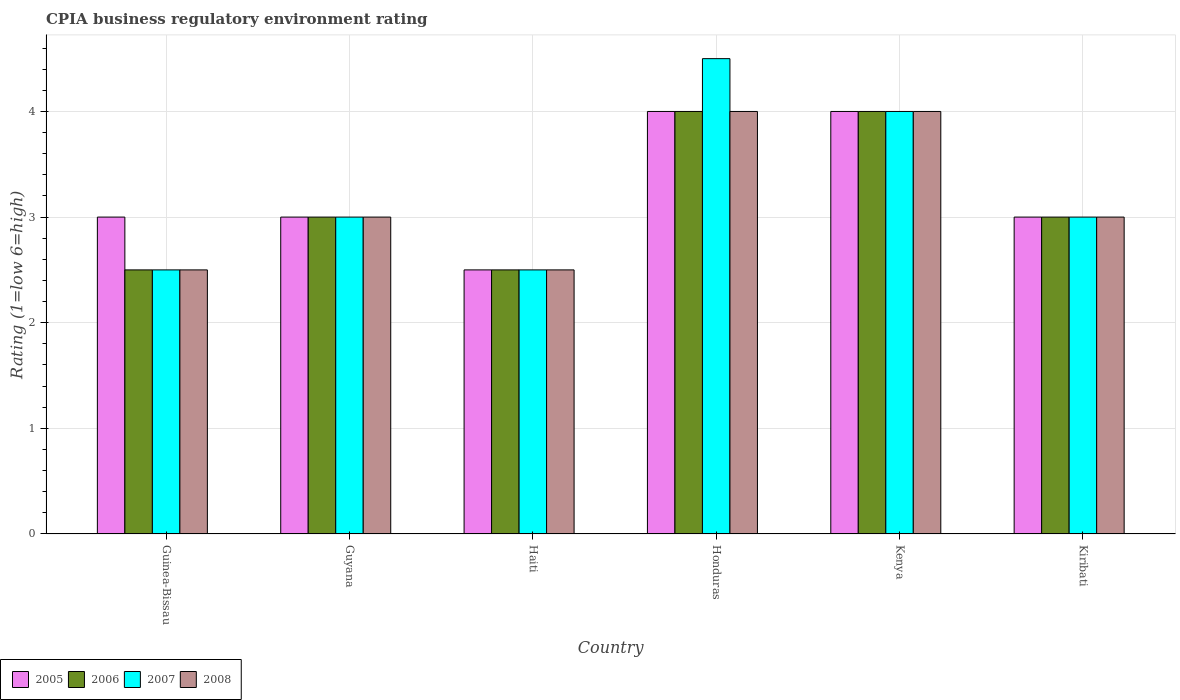How many different coloured bars are there?
Ensure brevity in your answer.  4. How many groups of bars are there?
Make the answer very short. 6. Are the number of bars on each tick of the X-axis equal?
Ensure brevity in your answer.  Yes. What is the label of the 1st group of bars from the left?
Provide a short and direct response. Guinea-Bissau. In how many cases, is the number of bars for a given country not equal to the number of legend labels?
Ensure brevity in your answer.  0. Across all countries, what is the maximum CPIA rating in 2006?
Your response must be concise. 4. Across all countries, what is the minimum CPIA rating in 2006?
Your response must be concise. 2.5. In which country was the CPIA rating in 2008 maximum?
Offer a terse response. Honduras. In which country was the CPIA rating in 2007 minimum?
Ensure brevity in your answer.  Guinea-Bissau. What is the total CPIA rating in 2007 in the graph?
Offer a terse response. 19.5. Is the CPIA rating in 2005 in Kenya less than that in Kiribati?
Provide a short and direct response. No. What is the difference between the highest and the lowest CPIA rating in 2008?
Your response must be concise. 1.5. Is it the case that in every country, the sum of the CPIA rating in 2008 and CPIA rating in 2007 is greater than the CPIA rating in 2005?
Give a very brief answer. Yes. How many bars are there?
Keep it short and to the point. 24. Are all the bars in the graph horizontal?
Your answer should be compact. No. Does the graph contain grids?
Keep it short and to the point. Yes. Where does the legend appear in the graph?
Your answer should be very brief. Bottom left. How many legend labels are there?
Your answer should be very brief. 4. How are the legend labels stacked?
Provide a succinct answer. Horizontal. What is the title of the graph?
Provide a succinct answer. CPIA business regulatory environment rating. Does "1993" appear as one of the legend labels in the graph?
Provide a short and direct response. No. What is the label or title of the X-axis?
Your response must be concise. Country. What is the Rating (1=low 6=high) in 2007 in Guinea-Bissau?
Your answer should be very brief. 2.5. What is the Rating (1=low 6=high) in 2008 in Guinea-Bissau?
Offer a terse response. 2.5. What is the Rating (1=low 6=high) in 2006 in Haiti?
Offer a very short reply. 2.5. What is the Rating (1=low 6=high) of 2007 in Haiti?
Keep it short and to the point. 2.5. What is the Rating (1=low 6=high) of 2008 in Haiti?
Keep it short and to the point. 2.5. What is the Rating (1=low 6=high) of 2005 in Honduras?
Offer a very short reply. 4. What is the Rating (1=low 6=high) in 2006 in Honduras?
Provide a short and direct response. 4. What is the Rating (1=low 6=high) of 2007 in Honduras?
Your answer should be compact. 4.5. What is the Rating (1=low 6=high) of 2005 in Kenya?
Your response must be concise. 4. What is the Rating (1=low 6=high) in 2007 in Kenya?
Provide a short and direct response. 4. What is the Rating (1=low 6=high) in 2006 in Kiribati?
Make the answer very short. 3. What is the Rating (1=low 6=high) in 2007 in Kiribati?
Your answer should be very brief. 3. Across all countries, what is the maximum Rating (1=low 6=high) in 2005?
Provide a short and direct response. 4. Across all countries, what is the maximum Rating (1=low 6=high) of 2006?
Your answer should be very brief. 4. Across all countries, what is the minimum Rating (1=low 6=high) of 2006?
Your answer should be compact. 2.5. Across all countries, what is the minimum Rating (1=low 6=high) in 2008?
Your answer should be very brief. 2.5. What is the total Rating (1=low 6=high) in 2005 in the graph?
Provide a succinct answer. 19.5. What is the total Rating (1=low 6=high) in 2006 in the graph?
Provide a short and direct response. 19. What is the total Rating (1=low 6=high) in 2007 in the graph?
Keep it short and to the point. 19.5. What is the total Rating (1=low 6=high) of 2008 in the graph?
Your answer should be very brief. 19. What is the difference between the Rating (1=low 6=high) in 2008 in Guinea-Bissau and that in Guyana?
Offer a very short reply. -0.5. What is the difference between the Rating (1=low 6=high) in 2006 in Guinea-Bissau and that in Haiti?
Your answer should be very brief. 0. What is the difference between the Rating (1=low 6=high) in 2007 in Guinea-Bissau and that in Haiti?
Provide a succinct answer. 0. What is the difference between the Rating (1=low 6=high) in 2008 in Guinea-Bissau and that in Haiti?
Your response must be concise. 0. What is the difference between the Rating (1=low 6=high) in 2006 in Guinea-Bissau and that in Honduras?
Your answer should be very brief. -1.5. What is the difference between the Rating (1=low 6=high) of 2005 in Guinea-Bissau and that in Kenya?
Your answer should be very brief. -1. What is the difference between the Rating (1=low 6=high) in 2007 in Guinea-Bissau and that in Kenya?
Your response must be concise. -1.5. What is the difference between the Rating (1=low 6=high) of 2006 in Guyana and that in Haiti?
Keep it short and to the point. 0.5. What is the difference between the Rating (1=low 6=high) in 2008 in Guyana and that in Honduras?
Offer a very short reply. -1. What is the difference between the Rating (1=low 6=high) of 2005 in Guyana and that in Kenya?
Keep it short and to the point. -1. What is the difference between the Rating (1=low 6=high) of 2007 in Guyana and that in Kenya?
Offer a terse response. -1. What is the difference between the Rating (1=low 6=high) in 2005 in Guyana and that in Kiribati?
Offer a very short reply. 0. What is the difference between the Rating (1=low 6=high) in 2007 in Guyana and that in Kiribati?
Offer a very short reply. 0. What is the difference between the Rating (1=low 6=high) of 2006 in Haiti and that in Honduras?
Provide a short and direct response. -1.5. What is the difference between the Rating (1=low 6=high) in 2008 in Haiti and that in Honduras?
Keep it short and to the point. -1.5. What is the difference between the Rating (1=low 6=high) of 2006 in Haiti and that in Kenya?
Provide a short and direct response. -1.5. What is the difference between the Rating (1=low 6=high) of 2007 in Haiti and that in Kenya?
Give a very brief answer. -1.5. What is the difference between the Rating (1=low 6=high) of 2008 in Haiti and that in Kenya?
Make the answer very short. -1.5. What is the difference between the Rating (1=low 6=high) of 2006 in Haiti and that in Kiribati?
Your response must be concise. -0.5. What is the difference between the Rating (1=low 6=high) of 2007 in Haiti and that in Kiribati?
Offer a very short reply. -0.5. What is the difference between the Rating (1=low 6=high) of 2008 in Haiti and that in Kiribati?
Offer a terse response. -0.5. What is the difference between the Rating (1=low 6=high) in 2005 in Honduras and that in Kenya?
Give a very brief answer. 0. What is the difference between the Rating (1=low 6=high) of 2006 in Honduras and that in Kenya?
Provide a short and direct response. 0. What is the difference between the Rating (1=low 6=high) in 2007 in Honduras and that in Kenya?
Provide a short and direct response. 0.5. What is the difference between the Rating (1=low 6=high) of 2005 in Honduras and that in Kiribati?
Your answer should be very brief. 1. What is the difference between the Rating (1=low 6=high) of 2006 in Honduras and that in Kiribati?
Make the answer very short. 1. What is the difference between the Rating (1=low 6=high) in 2007 in Honduras and that in Kiribati?
Make the answer very short. 1.5. What is the difference between the Rating (1=low 6=high) in 2008 in Honduras and that in Kiribati?
Offer a very short reply. 1. What is the difference between the Rating (1=low 6=high) in 2005 in Kenya and that in Kiribati?
Your answer should be compact. 1. What is the difference between the Rating (1=low 6=high) of 2008 in Kenya and that in Kiribati?
Provide a succinct answer. 1. What is the difference between the Rating (1=low 6=high) in 2005 in Guinea-Bissau and the Rating (1=low 6=high) in 2006 in Guyana?
Give a very brief answer. 0. What is the difference between the Rating (1=low 6=high) of 2005 in Guinea-Bissau and the Rating (1=low 6=high) of 2007 in Guyana?
Ensure brevity in your answer.  0. What is the difference between the Rating (1=low 6=high) of 2006 in Guinea-Bissau and the Rating (1=low 6=high) of 2008 in Guyana?
Provide a short and direct response. -0.5. What is the difference between the Rating (1=low 6=high) of 2007 in Guinea-Bissau and the Rating (1=low 6=high) of 2008 in Guyana?
Give a very brief answer. -0.5. What is the difference between the Rating (1=low 6=high) in 2005 in Guinea-Bissau and the Rating (1=low 6=high) in 2007 in Haiti?
Offer a terse response. 0.5. What is the difference between the Rating (1=low 6=high) of 2005 in Guinea-Bissau and the Rating (1=low 6=high) of 2008 in Honduras?
Make the answer very short. -1. What is the difference between the Rating (1=low 6=high) in 2006 in Guinea-Bissau and the Rating (1=low 6=high) in 2007 in Honduras?
Your response must be concise. -2. What is the difference between the Rating (1=low 6=high) of 2006 in Guinea-Bissau and the Rating (1=low 6=high) of 2008 in Honduras?
Your answer should be very brief. -1.5. What is the difference between the Rating (1=low 6=high) of 2005 in Guinea-Bissau and the Rating (1=low 6=high) of 2006 in Kenya?
Give a very brief answer. -1. What is the difference between the Rating (1=low 6=high) in 2005 in Guinea-Bissau and the Rating (1=low 6=high) in 2008 in Kenya?
Give a very brief answer. -1. What is the difference between the Rating (1=low 6=high) in 2006 in Guinea-Bissau and the Rating (1=low 6=high) in 2007 in Kenya?
Offer a terse response. -1.5. What is the difference between the Rating (1=low 6=high) in 2005 in Guinea-Bissau and the Rating (1=low 6=high) in 2006 in Kiribati?
Your response must be concise. 0. What is the difference between the Rating (1=low 6=high) of 2007 in Guinea-Bissau and the Rating (1=low 6=high) of 2008 in Kiribati?
Keep it short and to the point. -0.5. What is the difference between the Rating (1=low 6=high) in 2005 in Guyana and the Rating (1=low 6=high) in 2008 in Haiti?
Your answer should be very brief. 0.5. What is the difference between the Rating (1=low 6=high) in 2006 in Guyana and the Rating (1=low 6=high) in 2007 in Haiti?
Ensure brevity in your answer.  0.5. What is the difference between the Rating (1=low 6=high) in 2005 in Guyana and the Rating (1=low 6=high) in 2006 in Honduras?
Your answer should be compact. -1. What is the difference between the Rating (1=low 6=high) of 2005 in Guyana and the Rating (1=low 6=high) of 2007 in Honduras?
Provide a succinct answer. -1.5. What is the difference between the Rating (1=low 6=high) of 2006 in Guyana and the Rating (1=low 6=high) of 2007 in Honduras?
Make the answer very short. -1.5. What is the difference between the Rating (1=low 6=high) of 2007 in Guyana and the Rating (1=low 6=high) of 2008 in Honduras?
Keep it short and to the point. -1. What is the difference between the Rating (1=low 6=high) in 2005 in Guyana and the Rating (1=low 6=high) in 2007 in Kenya?
Ensure brevity in your answer.  -1. What is the difference between the Rating (1=low 6=high) in 2005 in Guyana and the Rating (1=low 6=high) in 2008 in Kenya?
Make the answer very short. -1. What is the difference between the Rating (1=low 6=high) of 2007 in Guyana and the Rating (1=low 6=high) of 2008 in Kenya?
Give a very brief answer. -1. What is the difference between the Rating (1=low 6=high) of 2005 in Guyana and the Rating (1=low 6=high) of 2008 in Kiribati?
Provide a succinct answer. 0. What is the difference between the Rating (1=low 6=high) of 2007 in Guyana and the Rating (1=low 6=high) of 2008 in Kiribati?
Offer a very short reply. 0. What is the difference between the Rating (1=low 6=high) in 2005 in Haiti and the Rating (1=low 6=high) in 2008 in Honduras?
Provide a succinct answer. -1.5. What is the difference between the Rating (1=low 6=high) of 2005 in Haiti and the Rating (1=low 6=high) of 2008 in Kenya?
Provide a short and direct response. -1.5. What is the difference between the Rating (1=low 6=high) of 2006 in Haiti and the Rating (1=low 6=high) of 2007 in Kenya?
Your answer should be compact. -1.5. What is the difference between the Rating (1=low 6=high) of 2007 in Haiti and the Rating (1=low 6=high) of 2008 in Kenya?
Keep it short and to the point. -1.5. What is the difference between the Rating (1=low 6=high) in 2005 in Haiti and the Rating (1=low 6=high) in 2007 in Kiribati?
Offer a very short reply. -0.5. What is the difference between the Rating (1=low 6=high) of 2006 in Haiti and the Rating (1=low 6=high) of 2008 in Kiribati?
Give a very brief answer. -0.5. What is the difference between the Rating (1=low 6=high) in 2005 in Honduras and the Rating (1=low 6=high) in 2008 in Kenya?
Provide a short and direct response. 0. What is the difference between the Rating (1=low 6=high) of 2006 in Honduras and the Rating (1=low 6=high) of 2007 in Kenya?
Your answer should be very brief. 0. What is the difference between the Rating (1=low 6=high) in 2006 in Honduras and the Rating (1=low 6=high) in 2008 in Kenya?
Your response must be concise. 0. What is the difference between the Rating (1=low 6=high) of 2005 in Honduras and the Rating (1=low 6=high) of 2006 in Kiribati?
Offer a terse response. 1. What is the difference between the Rating (1=low 6=high) in 2005 in Honduras and the Rating (1=low 6=high) in 2007 in Kiribati?
Your answer should be compact. 1. What is the difference between the Rating (1=low 6=high) of 2005 in Honduras and the Rating (1=low 6=high) of 2008 in Kiribati?
Make the answer very short. 1. What is the difference between the Rating (1=low 6=high) in 2007 in Honduras and the Rating (1=low 6=high) in 2008 in Kiribati?
Provide a succinct answer. 1.5. What is the difference between the Rating (1=low 6=high) of 2005 in Kenya and the Rating (1=low 6=high) of 2006 in Kiribati?
Your answer should be very brief. 1. What is the difference between the Rating (1=low 6=high) of 2005 in Kenya and the Rating (1=low 6=high) of 2007 in Kiribati?
Your answer should be very brief. 1. What is the difference between the Rating (1=low 6=high) of 2005 in Kenya and the Rating (1=low 6=high) of 2008 in Kiribati?
Provide a short and direct response. 1. What is the difference between the Rating (1=low 6=high) in 2006 in Kenya and the Rating (1=low 6=high) in 2007 in Kiribati?
Offer a terse response. 1. What is the difference between the Rating (1=low 6=high) in 2007 in Kenya and the Rating (1=low 6=high) in 2008 in Kiribati?
Provide a short and direct response. 1. What is the average Rating (1=low 6=high) of 2005 per country?
Make the answer very short. 3.25. What is the average Rating (1=low 6=high) of 2006 per country?
Your response must be concise. 3.17. What is the average Rating (1=low 6=high) of 2007 per country?
Provide a succinct answer. 3.25. What is the average Rating (1=low 6=high) in 2008 per country?
Provide a succinct answer. 3.17. What is the difference between the Rating (1=low 6=high) in 2005 and Rating (1=low 6=high) in 2008 in Guinea-Bissau?
Make the answer very short. 0.5. What is the difference between the Rating (1=low 6=high) in 2006 and Rating (1=low 6=high) in 2007 in Guinea-Bissau?
Offer a terse response. 0. What is the difference between the Rating (1=low 6=high) of 2007 and Rating (1=low 6=high) of 2008 in Guinea-Bissau?
Your answer should be very brief. 0. What is the difference between the Rating (1=low 6=high) in 2005 and Rating (1=low 6=high) in 2007 in Guyana?
Offer a very short reply. 0. What is the difference between the Rating (1=low 6=high) in 2006 and Rating (1=low 6=high) in 2007 in Guyana?
Your answer should be compact. 0. What is the difference between the Rating (1=low 6=high) of 2007 and Rating (1=low 6=high) of 2008 in Guyana?
Provide a succinct answer. 0. What is the difference between the Rating (1=low 6=high) of 2005 and Rating (1=low 6=high) of 2006 in Haiti?
Your response must be concise. 0. What is the difference between the Rating (1=low 6=high) in 2005 and Rating (1=low 6=high) in 2008 in Haiti?
Your answer should be compact. 0. What is the difference between the Rating (1=low 6=high) of 2005 and Rating (1=low 6=high) of 2006 in Honduras?
Make the answer very short. 0. What is the difference between the Rating (1=low 6=high) of 2006 and Rating (1=low 6=high) of 2008 in Honduras?
Give a very brief answer. 0. What is the difference between the Rating (1=low 6=high) in 2006 and Rating (1=low 6=high) in 2007 in Kenya?
Make the answer very short. 0. What is the difference between the Rating (1=low 6=high) of 2007 and Rating (1=low 6=high) of 2008 in Kenya?
Your response must be concise. 0. What is the difference between the Rating (1=low 6=high) in 2005 and Rating (1=low 6=high) in 2006 in Kiribati?
Ensure brevity in your answer.  0. What is the difference between the Rating (1=low 6=high) of 2005 and Rating (1=low 6=high) of 2007 in Kiribati?
Offer a terse response. 0. What is the difference between the Rating (1=low 6=high) in 2005 and Rating (1=low 6=high) in 2008 in Kiribati?
Offer a terse response. 0. What is the difference between the Rating (1=low 6=high) in 2006 and Rating (1=low 6=high) in 2007 in Kiribati?
Provide a short and direct response. 0. What is the ratio of the Rating (1=low 6=high) of 2007 in Guinea-Bissau to that in Guyana?
Your response must be concise. 0.83. What is the ratio of the Rating (1=low 6=high) in 2005 in Guinea-Bissau to that in Haiti?
Your response must be concise. 1.2. What is the ratio of the Rating (1=low 6=high) of 2008 in Guinea-Bissau to that in Haiti?
Your response must be concise. 1. What is the ratio of the Rating (1=low 6=high) in 2005 in Guinea-Bissau to that in Honduras?
Keep it short and to the point. 0.75. What is the ratio of the Rating (1=low 6=high) of 2006 in Guinea-Bissau to that in Honduras?
Offer a very short reply. 0.62. What is the ratio of the Rating (1=low 6=high) of 2007 in Guinea-Bissau to that in Honduras?
Provide a short and direct response. 0.56. What is the ratio of the Rating (1=low 6=high) in 2008 in Guinea-Bissau to that in Honduras?
Provide a short and direct response. 0.62. What is the ratio of the Rating (1=low 6=high) in 2005 in Guinea-Bissau to that in Kenya?
Provide a short and direct response. 0.75. What is the ratio of the Rating (1=low 6=high) of 2007 in Guinea-Bissau to that in Kenya?
Provide a short and direct response. 0.62. What is the ratio of the Rating (1=low 6=high) in 2006 in Guinea-Bissau to that in Kiribati?
Ensure brevity in your answer.  0.83. What is the ratio of the Rating (1=low 6=high) in 2007 in Guinea-Bissau to that in Kiribati?
Offer a very short reply. 0.83. What is the ratio of the Rating (1=low 6=high) in 2007 in Guyana to that in Honduras?
Ensure brevity in your answer.  0.67. What is the ratio of the Rating (1=low 6=high) of 2008 in Guyana to that in Honduras?
Provide a short and direct response. 0.75. What is the ratio of the Rating (1=low 6=high) of 2008 in Guyana to that in Kenya?
Keep it short and to the point. 0.75. What is the ratio of the Rating (1=low 6=high) of 2007 in Guyana to that in Kiribati?
Make the answer very short. 1. What is the ratio of the Rating (1=low 6=high) of 2008 in Guyana to that in Kiribati?
Your answer should be compact. 1. What is the ratio of the Rating (1=low 6=high) in 2005 in Haiti to that in Honduras?
Your answer should be very brief. 0.62. What is the ratio of the Rating (1=low 6=high) of 2006 in Haiti to that in Honduras?
Keep it short and to the point. 0.62. What is the ratio of the Rating (1=low 6=high) of 2007 in Haiti to that in Honduras?
Your answer should be very brief. 0.56. What is the ratio of the Rating (1=low 6=high) in 2008 in Haiti to that in Honduras?
Provide a short and direct response. 0.62. What is the ratio of the Rating (1=low 6=high) of 2008 in Haiti to that in Kenya?
Make the answer very short. 0.62. What is the ratio of the Rating (1=low 6=high) in 2005 in Haiti to that in Kiribati?
Keep it short and to the point. 0.83. What is the ratio of the Rating (1=low 6=high) in 2006 in Haiti to that in Kiribati?
Provide a succinct answer. 0.83. What is the ratio of the Rating (1=low 6=high) of 2007 in Haiti to that in Kiribati?
Keep it short and to the point. 0.83. What is the ratio of the Rating (1=low 6=high) of 2008 in Honduras to that in Kenya?
Offer a very short reply. 1. What is the ratio of the Rating (1=low 6=high) of 2005 in Honduras to that in Kiribati?
Give a very brief answer. 1.33. What is the ratio of the Rating (1=low 6=high) of 2006 in Honduras to that in Kiribati?
Give a very brief answer. 1.33. What is the ratio of the Rating (1=low 6=high) in 2007 in Honduras to that in Kiribati?
Give a very brief answer. 1.5. What is the ratio of the Rating (1=low 6=high) in 2008 in Kenya to that in Kiribati?
Keep it short and to the point. 1.33. What is the difference between the highest and the second highest Rating (1=low 6=high) of 2006?
Provide a succinct answer. 0. What is the difference between the highest and the lowest Rating (1=low 6=high) in 2006?
Offer a very short reply. 1.5. 